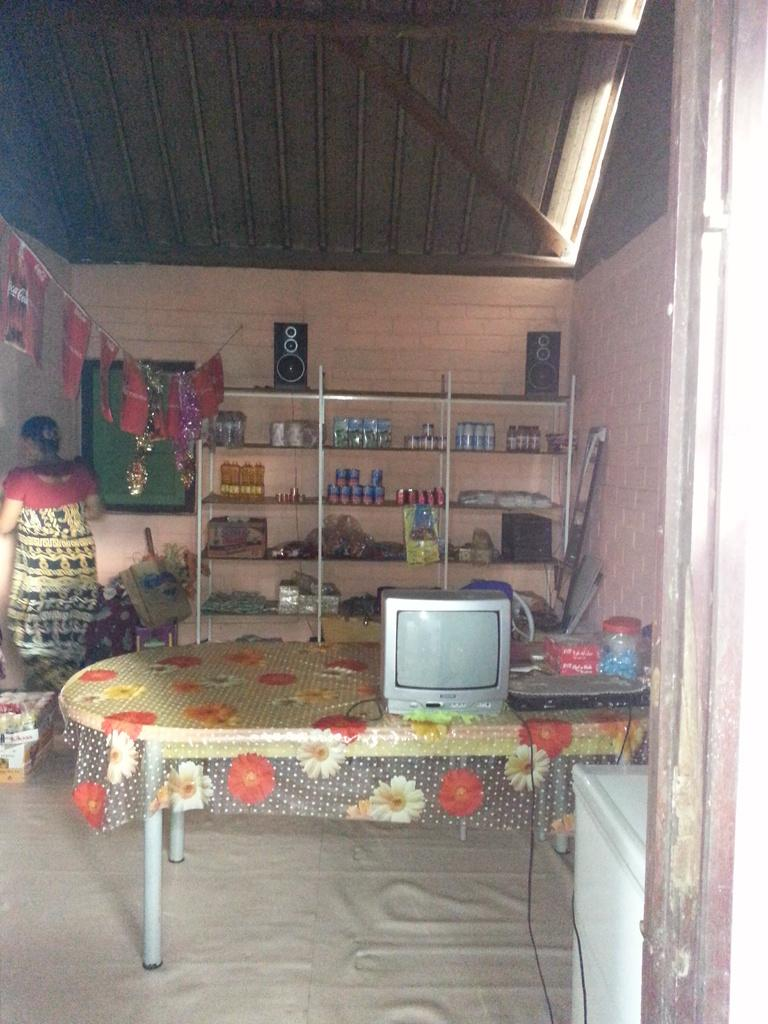What is the main subject in the image? There is a woman standing in the image. What can be seen in the background of the image? There are speakers visible in the background of the image, as well as few other unspecified items. What is on the table in the image? A machine and a television are present on the table in the image. What type of destruction can be seen in the image? There is no destruction present in the image. What type of voyage is the woman embarking on in the image? There is no indication of a voyage in the image; the woman is simply standing. 